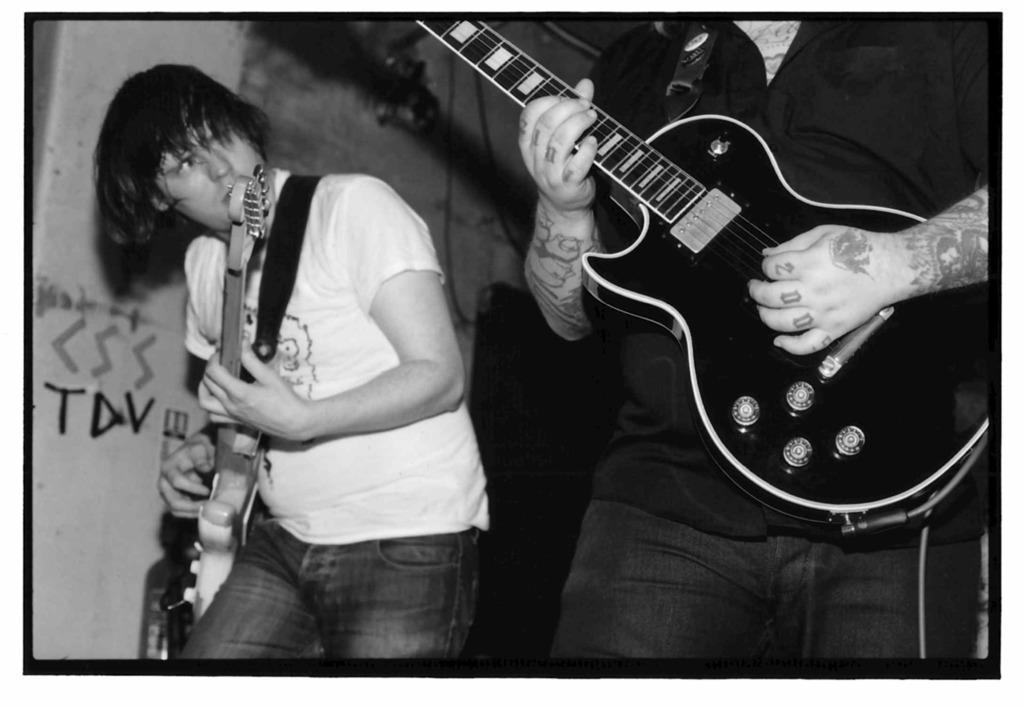In one or two sentences, can you explain what this image depicts? On the right a person is playing a guitar. On the left another person wearing a white t shirt is playing guitar. In the background there is a wall. 